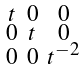Convert formula to latex. <formula><loc_0><loc_0><loc_500><loc_500>\begin{smallmatrix} t & 0 & 0 \\ 0 & t & 0 \\ 0 & 0 & t ^ { - 2 } \end{smallmatrix}</formula> 